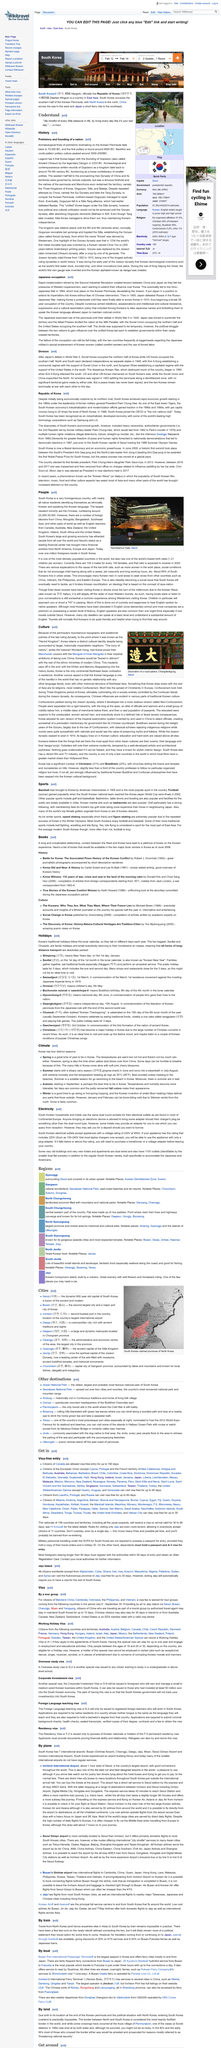Indicate a few pertinent items in this graphic. There are between 20,000 and 30,000 Chinese people living in South Korea. It is estimated that over one million foreigners reside in South Korea. Seoul, the capital city of South Korea, is located in the southern part of the country. 